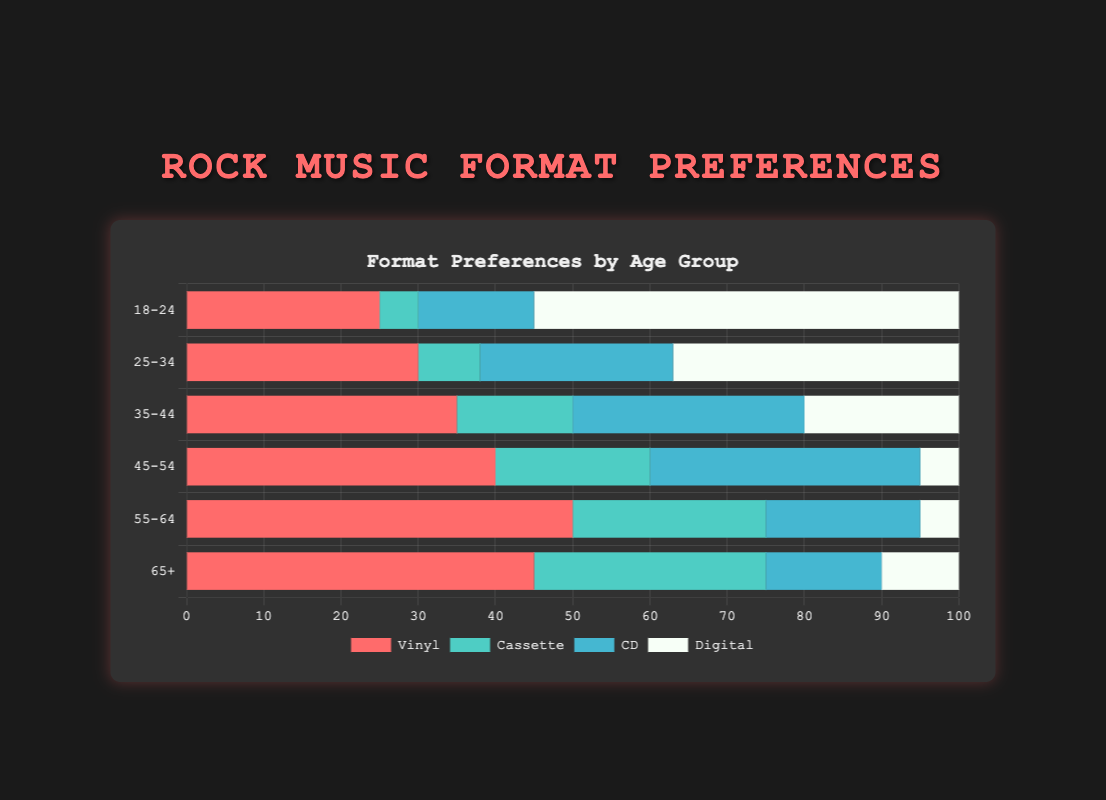What's the most preferred music format among the 18-24 age group? To find the answer, we look at the bar heights of each format (vinyl, cassette, CD, digital) for the 18-24 age group. The digital format has the highest bar, indicating it's the most preferred.
Answer: digital Which age group has the highest preference for vinyl? By comparing the bar heights for the vinyl format across all age groups, the 55-64 age group has the highest bar, indicating the highest preference for vinyl.
Answer: 55-64 Do people aged 45-54 prefer CDs or cassettes more? For the 45-54 age group, comparing the bars for CDs and cassettes shows the bar for CDs is higher. Therefore, CDs are preferred more.
Answer: CDs What's the combined preference for cassettes and digital formats among the 25-34 age group? Summing the cassette (8) and digital (37) preferences for the 25-34 age group gives a total of 8 + 37 = 45.
Answer: 45 In the 65+ age group, how does the preference for digital compare to vinyl? Comparing the bar heights for digital and vinyl in the 65+ age group, the vinyl bar is much higher than the digital bar, indicating a higher preference for vinyl.
Answer: lower Across all age groups, which format has the highest single preference value and what age group does it belong to? By scanning the bar heights for all formats across all age groups, the digital format for the 18-24 age group stands out with a bar height of 55, which is the highest single value.
Answer: digital, 18-24 What is the average preference for CDs across all age groups? Adding all the preference values for CDs across age groups (15 + 25 + 30 + 35 + 20 + 15) gives 140. Dividing this by the number of age groups (6) results in 140 / 6 ≈ 23.33.
Answer: 23.33 Which age group has the lowest combined preference for vinyl and cassettes? Summing the vinyl and cassette preferences for each age group, the calculations are: 18-24 = 25 + 5 = 30, 25-34 = 30 + 8 = 38, 35-44 = 35 + 15 = 50, 45-54 = 40 + 20 = 60, 55-64 = 50 + 25 = 75, 65+ = 45 + 30 = 75. The 18-24 age group has the lowest sum of 30.
Answer: 18-24 For the 35-44 age group, which preference is closer to the preference for digital: vinyl or CD? Comparing the digital preference (20) with the vinyl (35) and CD (30) preferences in the 35-44 age group, 30 (CD) is closer to 20 than 35 (vinyl).
Answer: CD What is the difference in digital format preference between the 25-34 and the 45-54 age groups? Subtracting the digital preference for the 45-54 age group (5) from the 25-34 age group (37) gives 37 - 5 = 32.
Answer: 32 